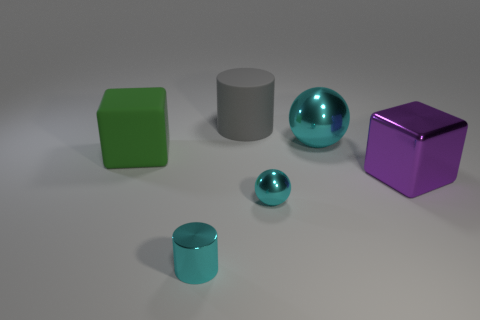Add 3 tiny blue cylinders. How many objects exist? 9 Subtract all spheres. How many objects are left? 4 Add 4 small shiny balls. How many small shiny balls are left? 5 Add 1 cyan shiny cylinders. How many cyan shiny cylinders exist? 2 Subtract 0 green spheres. How many objects are left? 6 Subtract all large yellow rubber cubes. Subtract all large purple objects. How many objects are left? 5 